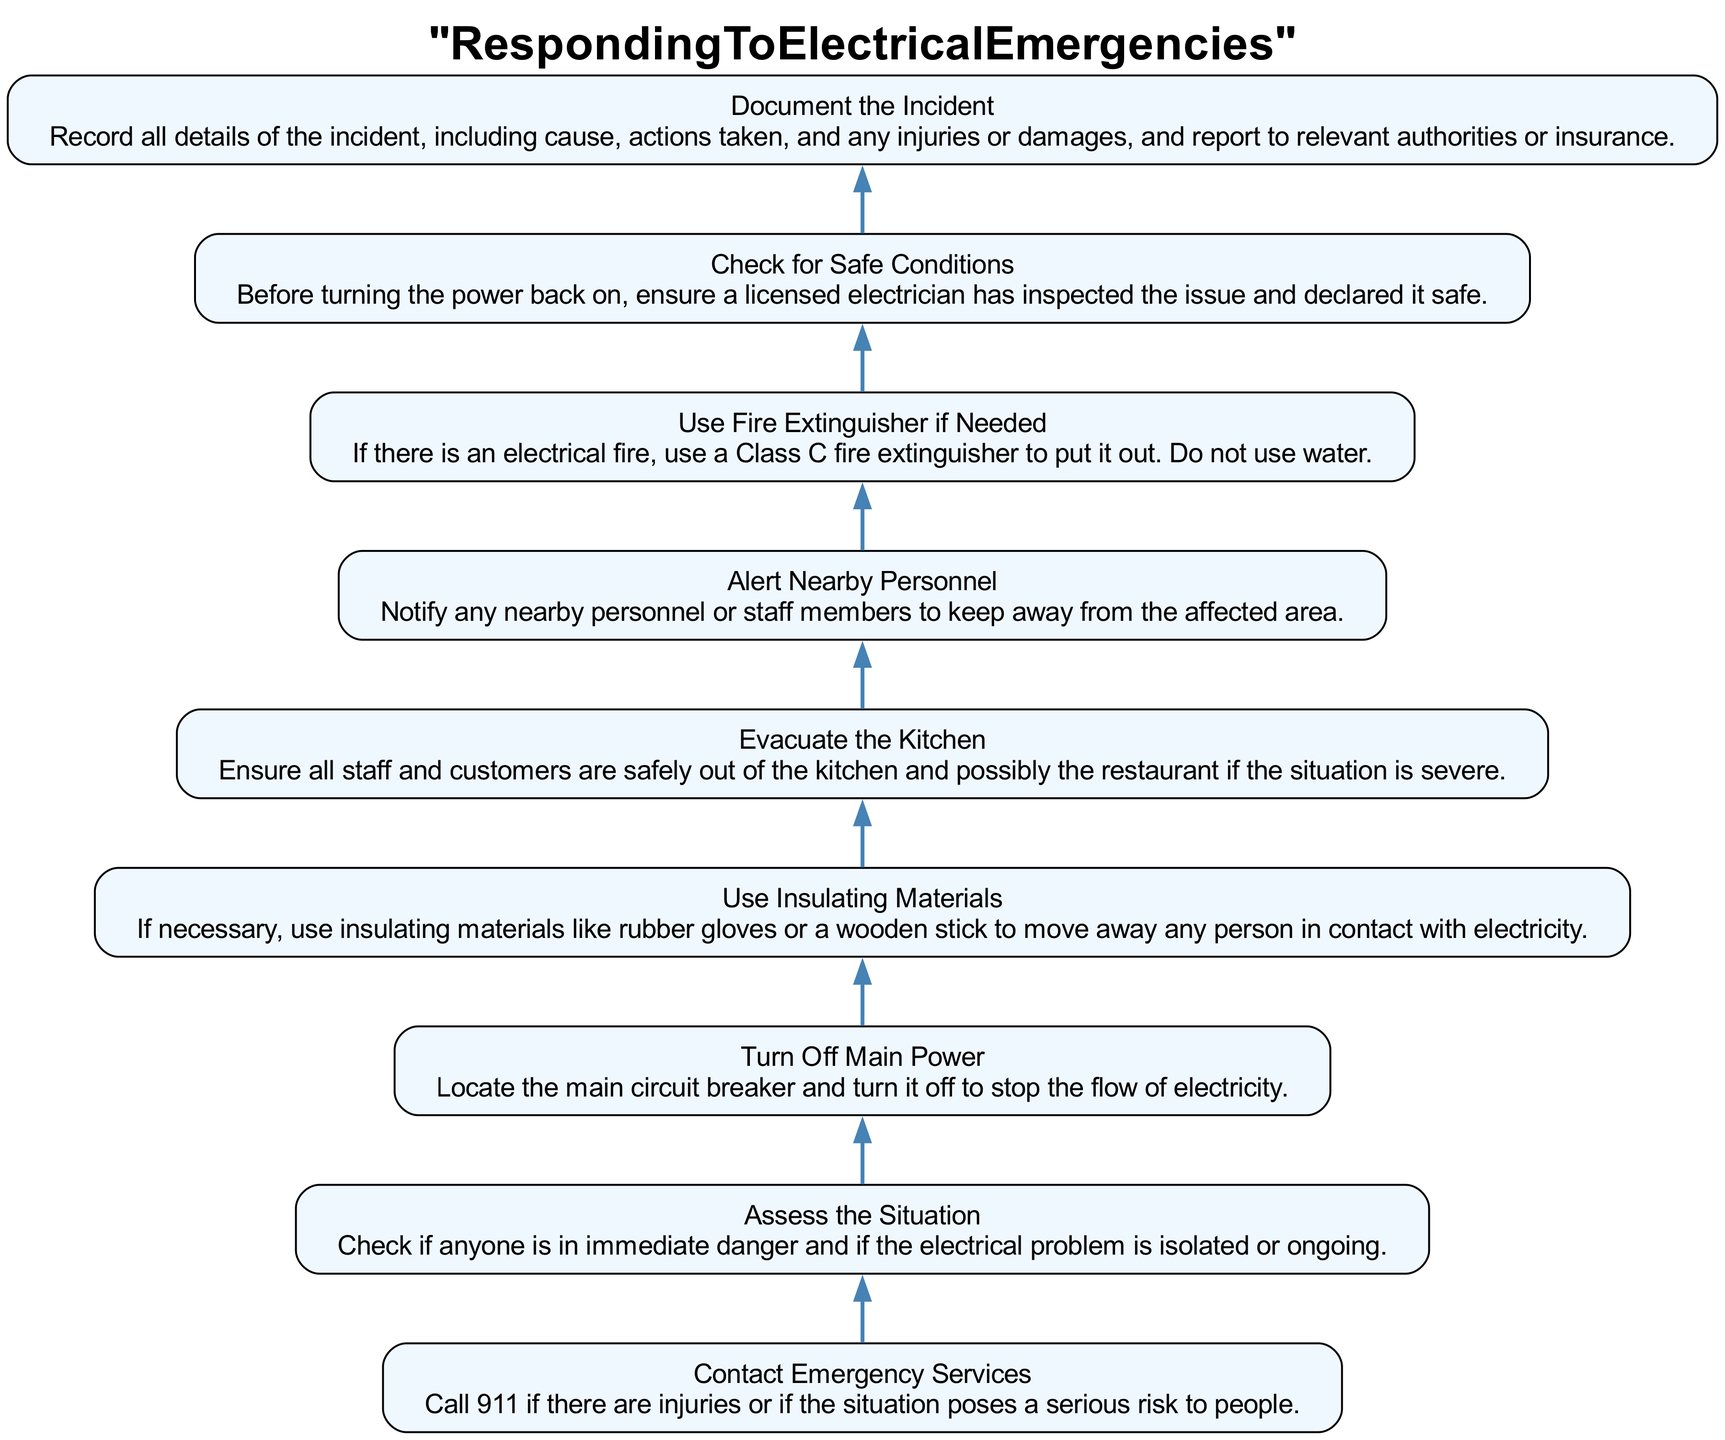What is the first step to take in an electrical emergency? The flowchart indicates that the first step is to "Contact Emergency Services." This is the action you should take immediately if there are injuries or if the situation poses a serious risk to people.
Answer: Contact Emergency Services How many total steps are there in the diagram? By counting the steps listed in the flowchart from bottom to top, there are a total of nine steps outlined.
Answer: Nine What action should be taken after assessing the situation? After "Assess the Situation," the next step in the flowchart is to "Turn Off Main Power," indicating the importance of ensuring safety by cutting off electricity.
Answer: Turn Off Main Power What does the flowchart suggest using if someone is in contact with electricity? The flowchart advises using insulating materials like rubber gloves or a wooden stick to safely move away any person in contact with electricity if necessary.
Answer: Use Insulating Materials In what order should the following actions occur: evacuate the kitchen, alert nearby personnel, check for safe conditions? The flowchart sequence indicates you first "Evacuate the Kitchen," then "Alert Nearby Personnel," and finally "Check for Safe Conditions." This order emphasizes the importance of immediate evacuation before notifying others and ensuring safety conditions.
Answer: Evacuate the Kitchen, Alert Nearby Personnel, Check for Safe Conditions What is the purpose of documenting the incident? The flowchart specifies that "Document the Incident" is crucial for recording details, including the cause, actions taken, and any injuries or damages, for reporting to relevant authorities or insurance. This highlights the importance of keeping accurate records after an emergency.
Answer: Record all details of the incident Which step follows using a fire extinguisher if needed? According to the flowchart, after "Use Fire Extinguisher if Needed," the next step is to "Check for Safe Conditions." This ensures that any fire is addressed before proceeding to check the safety of the electrical systems.
Answer: Check for Safe Conditions 